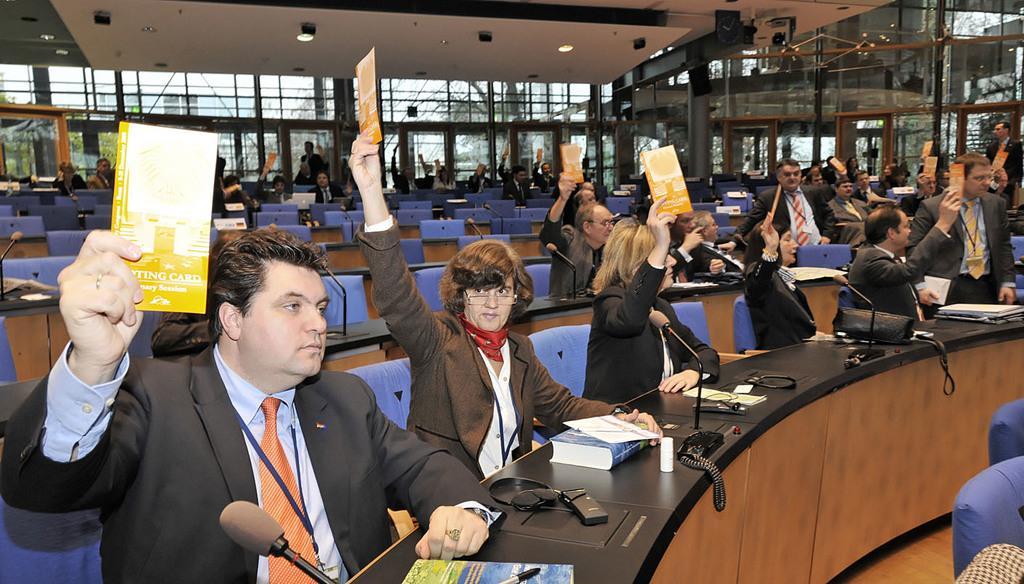Can you describe this image briefly? In this picture I can see many people who are sitting on the chair near to the table and some people are holding the pamphlet. On the table I can see the mics, books, headphones, papers, pens and other objects. In the background I can see the doors and glass partition. Through the door I can see the sky and trees. 